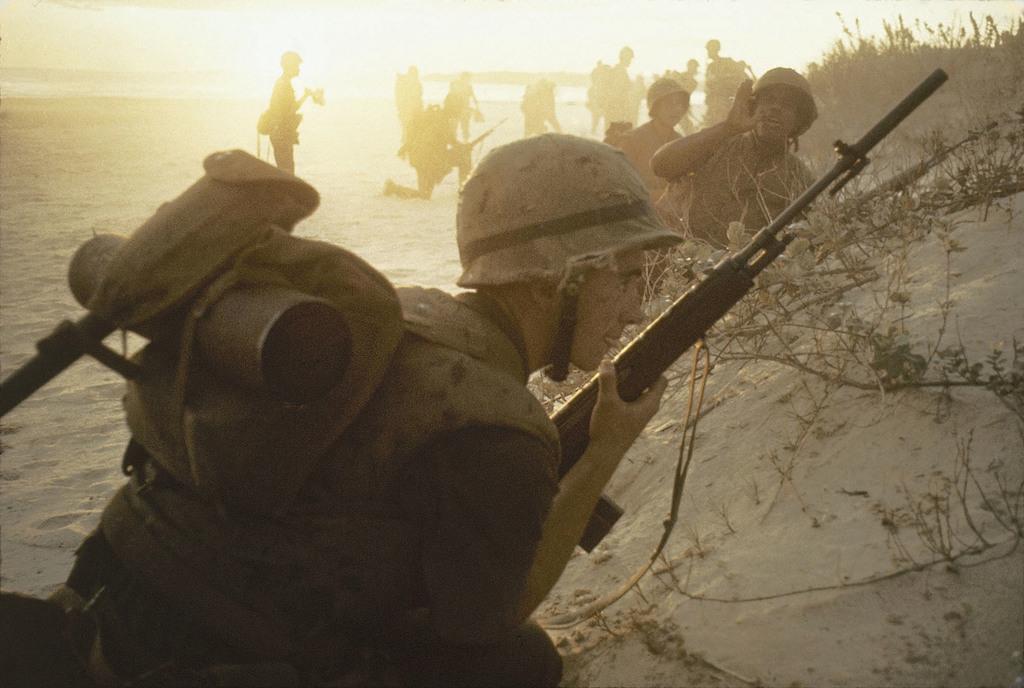How would you summarize this image in a sentence or two? There are few people standing and few people sitting in squat position. They are holding the weapons. I think these are the branches. This looks like the sand. 